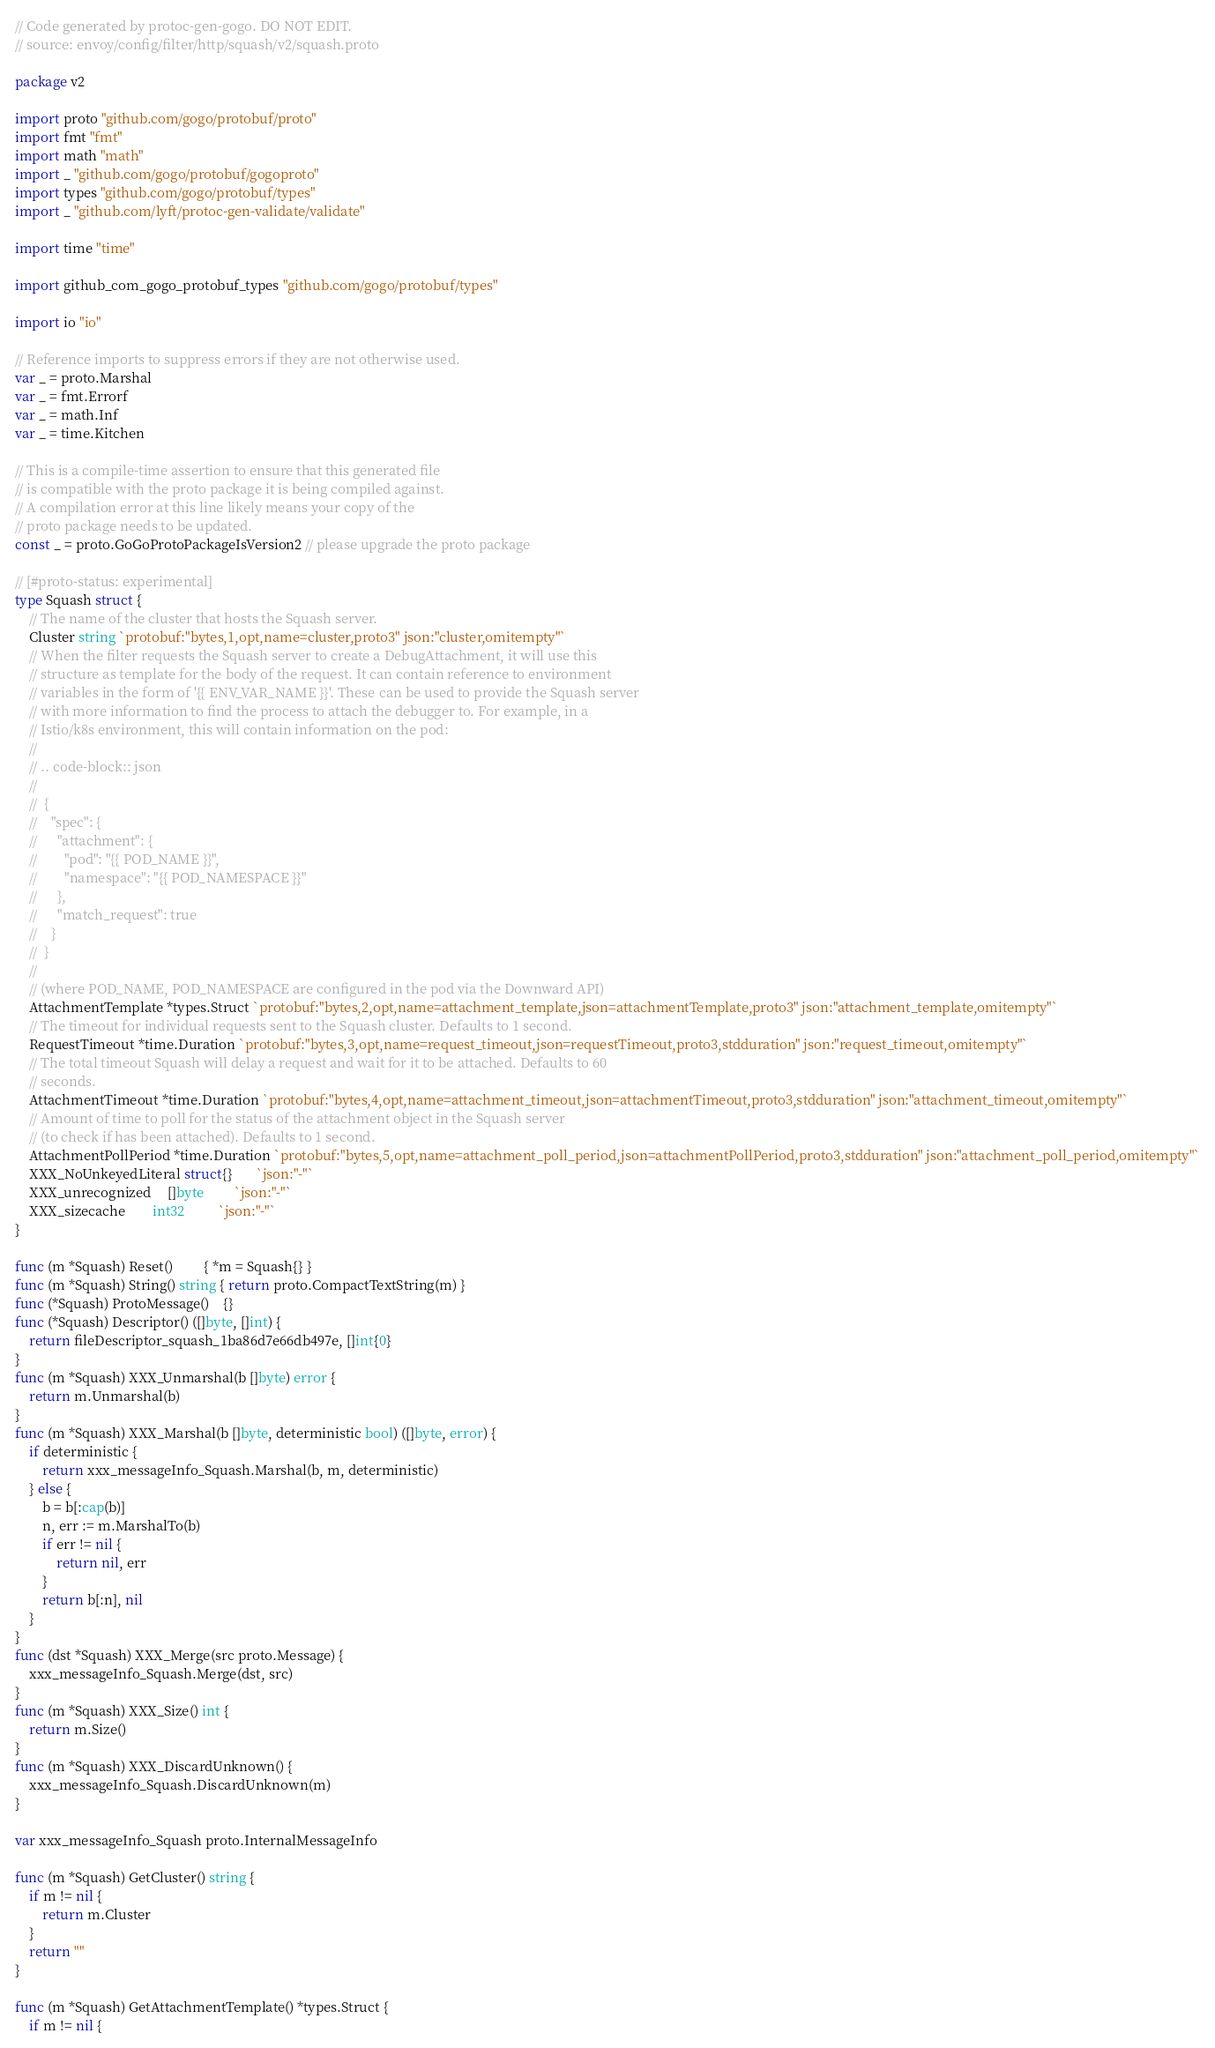<code> <loc_0><loc_0><loc_500><loc_500><_Go_>// Code generated by protoc-gen-gogo. DO NOT EDIT.
// source: envoy/config/filter/http/squash/v2/squash.proto

package v2

import proto "github.com/gogo/protobuf/proto"
import fmt "fmt"
import math "math"
import _ "github.com/gogo/protobuf/gogoproto"
import types "github.com/gogo/protobuf/types"
import _ "github.com/lyft/protoc-gen-validate/validate"

import time "time"

import github_com_gogo_protobuf_types "github.com/gogo/protobuf/types"

import io "io"

// Reference imports to suppress errors if they are not otherwise used.
var _ = proto.Marshal
var _ = fmt.Errorf
var _ = math.Inf
var _ = time.Kitchen

// This is a compile-time assertion to ensure that this generated file
// is compatible with the proto package it is being compiled against.
// A compilation error at this line likely means your copy of the
// proto package needs to be updated.
const _ = proto.GoGoProtoPackageIsVersion2 // please upgrade the proto package

// [#proto-status: experimental]
type Squash struct {
	// The name of the cluster that hosts the Squash server.
	Cluster string `protobuf:"bytes,1,opt,name=cluster,proto3" json:"cluster,omitempty"`
	// When the filter requests the Squash server to create a DebugAttachment, it will use this
	// structure as template for the body of the request. It can contain reference to environment
	// variables in the form of '{{ ENV_VAR_NAME }}'. These can be used to provide the Squash server
	// with more information to find the process to attach the debugger to. For example, in a
	// Istio/k8s environment, this will contain information on the pod:
	//
	// .. code-block:: json
	//
	//  {
	//    "spec": {
	//      "attachment": {
	//        "pod": "{{ POD_NAME }}",
	//        "namespace": "{{ POD_NAMESPACE }}"
	//      },
	//      "match_request": true
	//    }
	//  }
	//
	// (where POD_NAME, POD_NAMESPACE are configured in the pod via the Downward API)
	AttachmentTemplate *types.Struct `protobuf:"bytes,2,opt,name=attachment_template,json=attachmentTemplate,proto3" json:"attachment_template,omitempty"`
	// The timeout for individual requests sent to the Squash cluster. Defaults to 1 second.
	RequestTimeout *time.Duration `protobuf:"bytes,3,opt,name=request_timeout,json=requestTimeout,proto3,stdduration" json:"request_timeout,omitempty"`
	// The total timeout Squash will delay a request and wait for it to be attached. Defaults to 60
	// seconds.
	AttachmentTimeout *time.Duration `protobuf:"bytes,4,opt,name=attachment_timeout,json=attachmentTimeout,proto3,stdduration" json:"attachment_timeout,omitempty"`
	// Amount of time to poll for the status of the attachment object in the Squash server
	// (to check if has been attached). Defaults to 1 second.
	AttachmentPollPeriod *time.Duration `protobuf:"bytes,5,opt,name=attachment_poll_period,json=attachmentPollPeriod,proto3,stdduration" json:"attachment_poll_period,omitempty"`
	XXX_NoUnkeyedLiteral struct{}       `json:"-"`
	XXX_unrecognized     []byte         `json:"-"`
	XXX_sizecache        int32          `json:"-"`
}

func (m *Squash) Reset()         { *m = Squash{} }
func (m *Squash) String() string { return proto.CompactTextString(m) }
func (*Squash) ProtoMessage()    {}
func (*Squash) Descriptor() ([]byte, []int) {
	return fileDescriptor_squash_1ba86d7e66db497e, []int{0}
}
func (m *Squash) XXX_Unmarshal(b []byte) error {
	return m.Unmarshal(b)
}
func (m *Squash) XXX_Marshal(b []byte, deterministic bool) ([]byte, error) {
	if deterministic {
		return xxx_messageInfo_Squash.Marshal(b, m, deterministic)
	} else {
		b = b[:cap(b)]
		n, err := m.MarshalTo(b)
		if err != nil {
			return nil, err
		}
		return b[:n], nil
	}
}
func (dst *Squash) XXX_Merge(src proto.Message) {
	xxx_messageInfo_Squash.Merge(dst, src)
}
func (m *Squash) XXX_Size() int {
	return m.Size()
}
func (m *Squash) XXX_DiscardUnknown() {
	xxx_messageInfo_Squash.DiscardUnknown(m)
}

var xxx_messageInfo_Squash proto.InternalMessageInfo

func (m *Squash) GetCluster() string {
	if m != nil {
		return m.Cluster
	}
	return ""
}

func (m *Squash) GetAttachmentTemplate() *types.Struct {
	if m != nil {</code> 